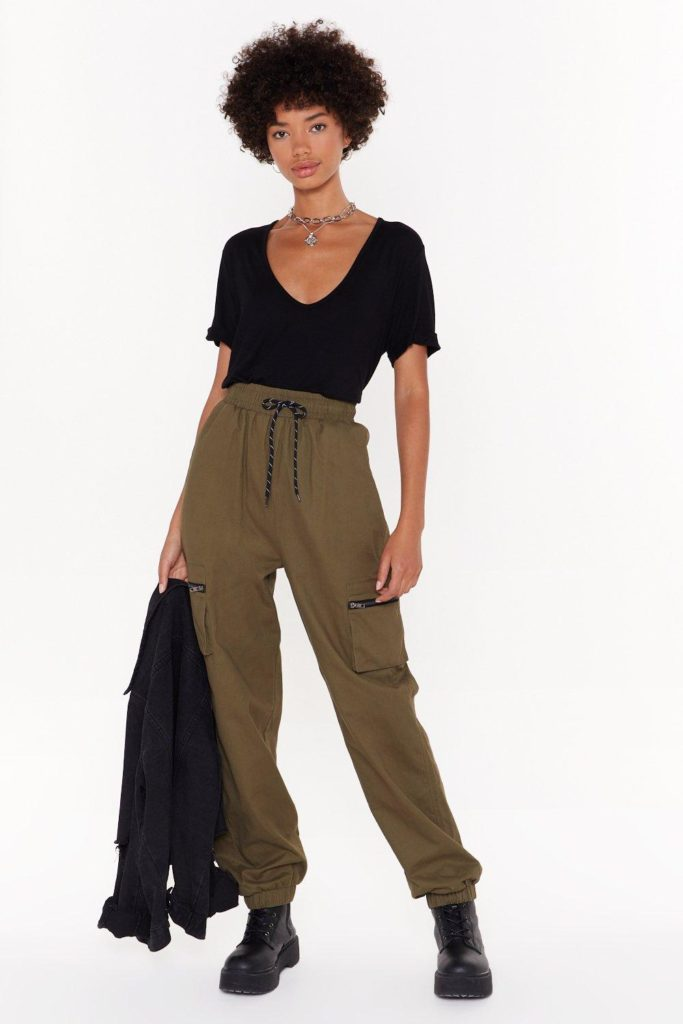If this individual were a character in a movie, what genre would the movie be and why? Given the individual's confident and composed demeanor, they would likely fit perfectly into an action-adventure movie. The cargo pants and sturdy boots suggest readiness for dynamic movement and exploration, while the black t-shirt adds a touch of sleekness and modernity. This outfit and the overall look would be well-suited for a character who undertakes thrilling adventures or embarks on a journey filled with challenges and excitement. Expand on the kind of adventure this character might go on. This character could be on a mission to uncover ancient secrets in a hidden temple deep within an uncharted jungle. Equipped with both physical agility and sharp intellect, they navigate treacherous paths, decipher cryptic symbols, and confront imposing enemies and natural obstacles. Their journey isn't just about the external challenges, but also involves an internal arc of discovering personal strength and resilience. Each step of their adventure reveals breathtaking landscapes, mystical artifacts, and moments of intense action, ultimately leading to a groundbreaking discovery that can change the world's understanding of history. 